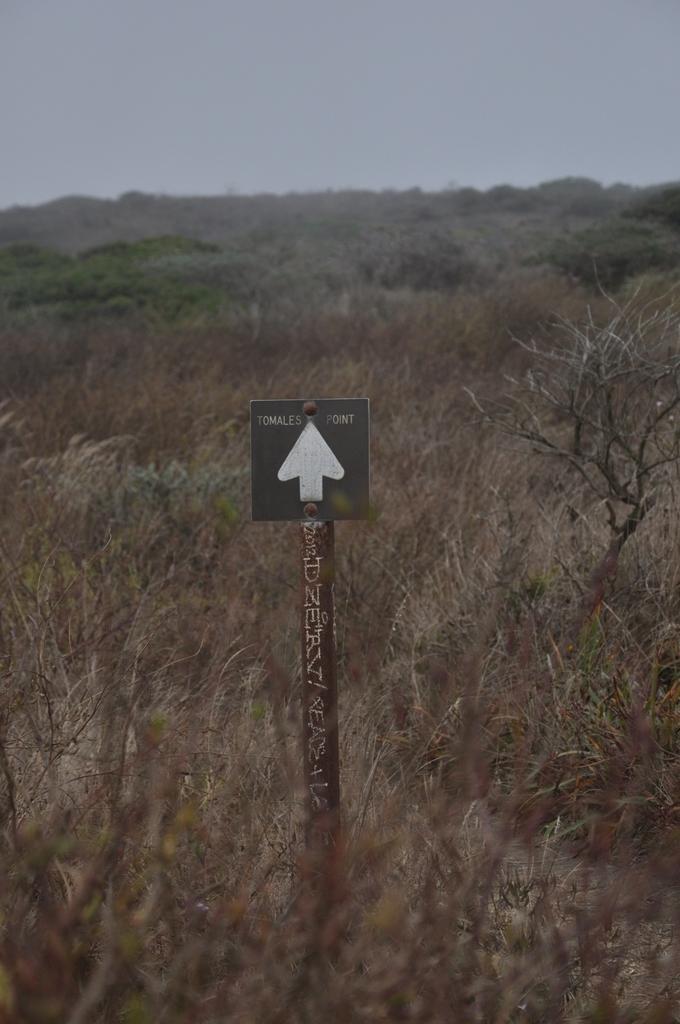How would you summarize this image in a sentence or two? In this picture we can see a pole with a signboard. Behind the pole there are trees and a sky. 